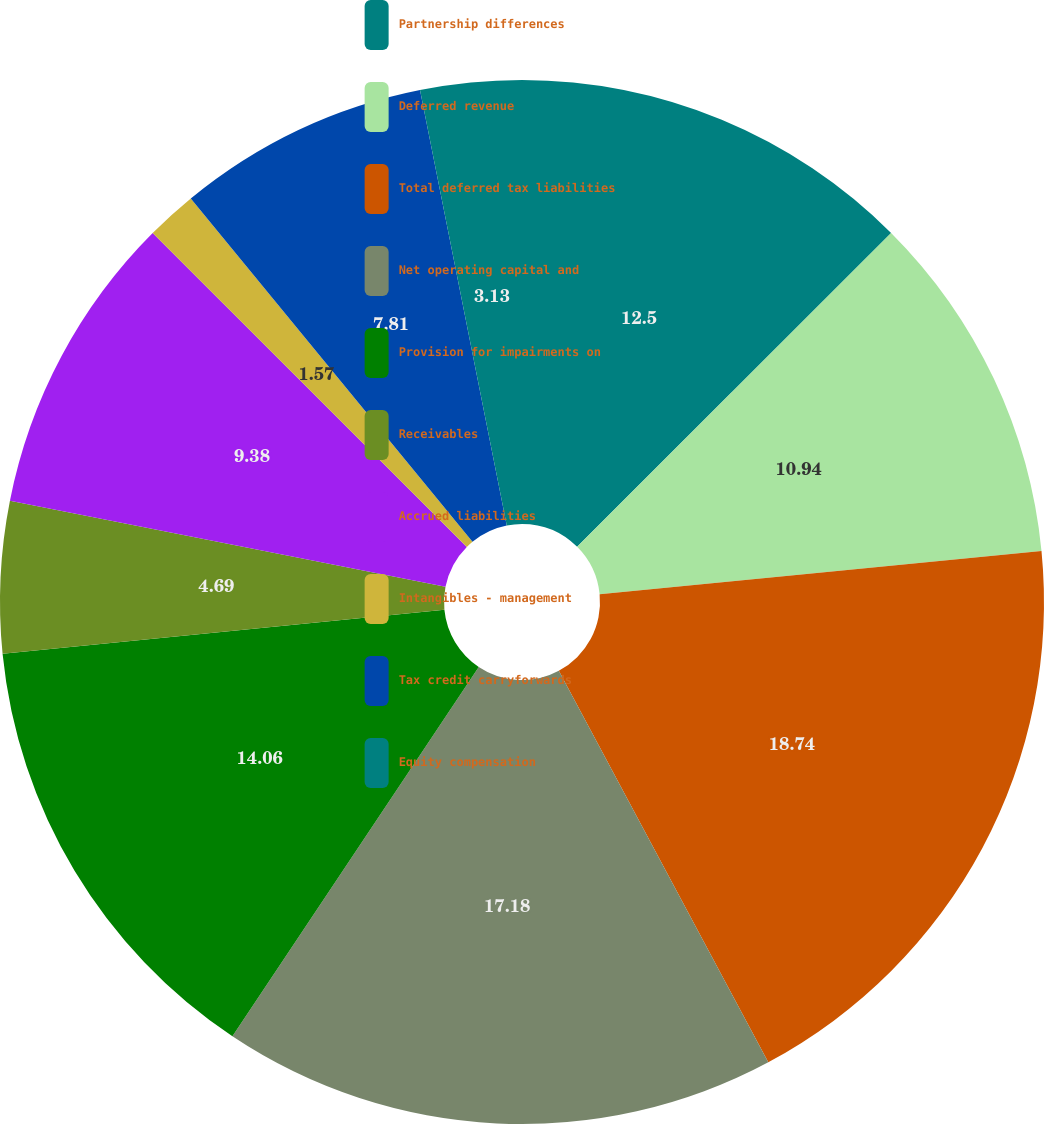Convert chart to OTSL. <chart><loc_0><loc_0><loc_500><loc_500><pie_chart><fcel>Partnership differences<fcel>Deferred revenue<fcel>Total deferred tax liabilities<fcel>Net operating capital and<fcel>Provision for impairments on<fcel>Receivables<fcel>Accrued liabilities<fcel>Intangibles - management<fcel>Tax credit carryforwards<fcel>Equity compensation<nl><fcel>12.5%<fcel>10.94%<fcel>18.74%<fcel>17.18%<fcel>14.06%<fcel>4.69%<fcel>9.38%<fcel>1.57%<fcel>7.81%<fcel>3.13%<nl></chart> 